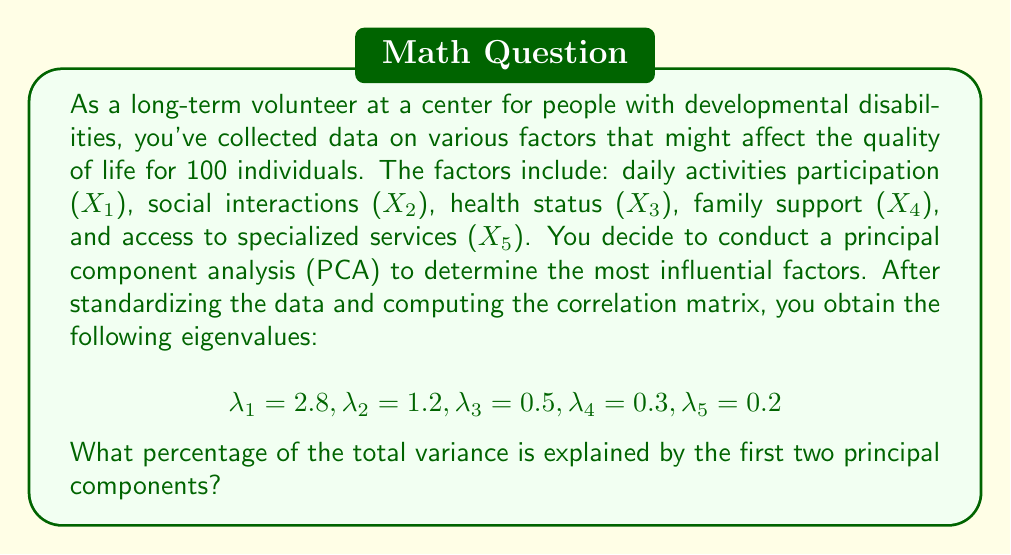Provide a solution to this math problem. To solve this problem, we need to follow these steps:

1) Recall that in PCA, each eigenvalue represents the amount of variance explained by its corresponding principal component.

2) The total variance in a dataset with standardized variables is equal to the number of variables. In this case, we have 5 variables, so the total variance is 5.

3) To calculate the percentage of variance explained by the first two principal components, we need to:
   a) Sum the eigenvalues of the first two components
   b) Divide this sum by the total variance
   c) Multiply by 100 to get the percentage

4) Let's perform the calculation:

   Sum of first two eigenvalues: $\lambda_1 + \lambda_2 = 2.8 + 1.2 = 4$

   Percentage of variance explained:

   $$\frac{4}{5} \times 100 = 0.8 \times 100 = 80\%$$

Therefore, the first two principal components explain 80% of the total variance in the dataset.

This result suggests that these two components capture a significant amount of the variation in the quality of life factors for individuals with developmental disabilities, and may be sufficient for further analysis or dimensionality reduction.
Answer: 80% 